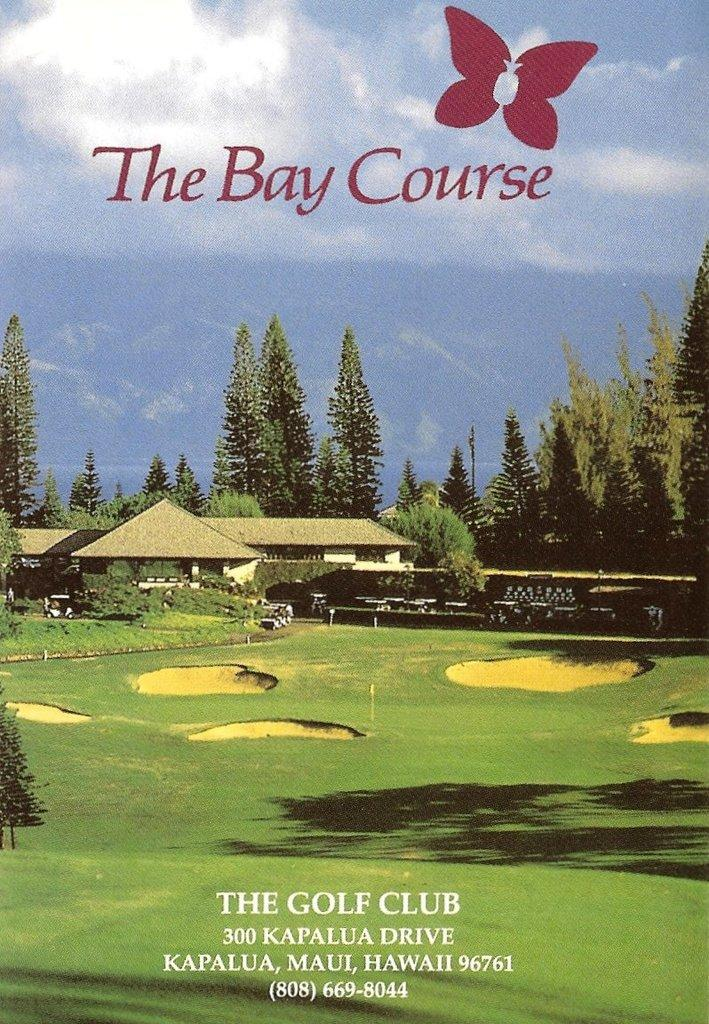Provide a one-sentence caption for the provided image. Promo flyer for The Bay Course golf Club in Hawaii. 